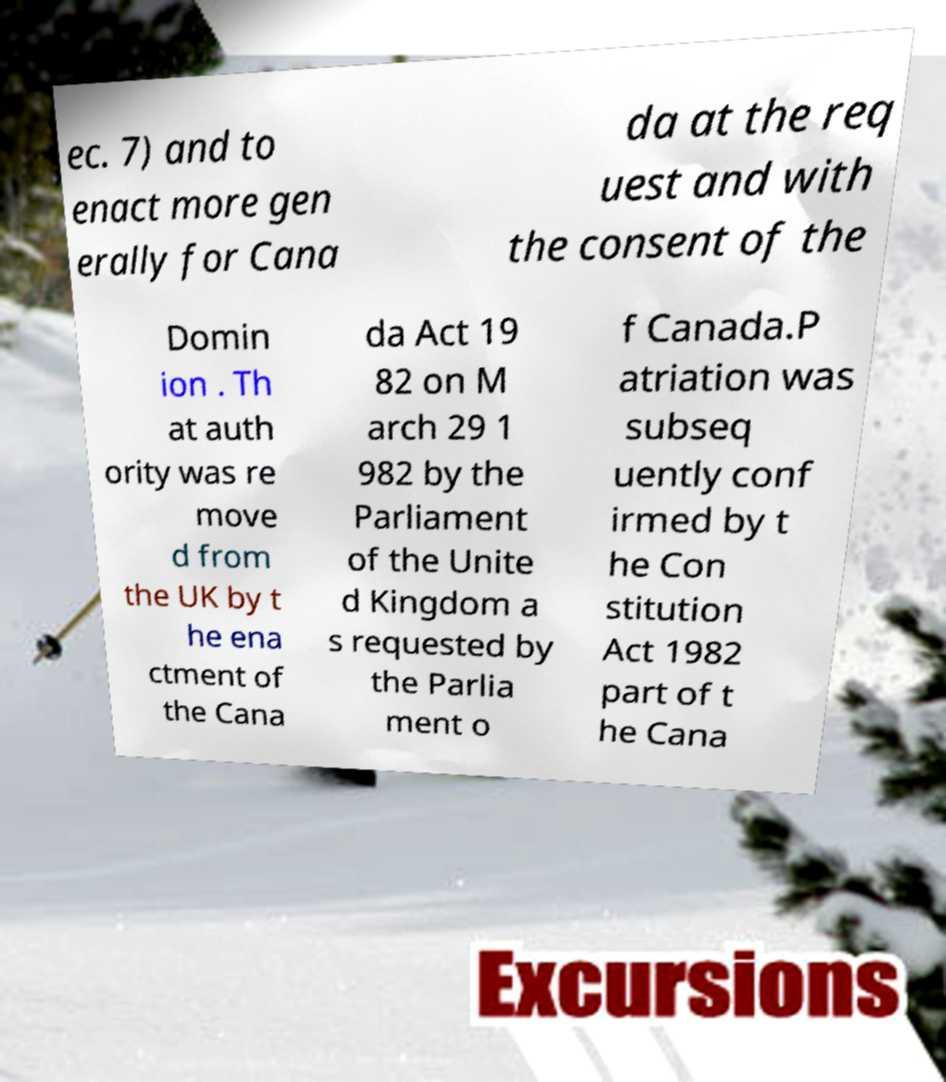For documentation purposes, I need the text within this image transcribed. Could you provide that? ec. 7) and to enact more gen erally for Cana da at the req uest and with the consent of the Domin ion . Th at auth ority was re move d from the UK by t he ena ctment of the Cana da Act 19 82 on M arch 29 1 982 by the Parliament of the Unite d Kingdom a s requested by the Parlia ment o f Canada.P atriation was subseq uently conf irmed by t he Con stitution Act 1982 part of t he Cana 